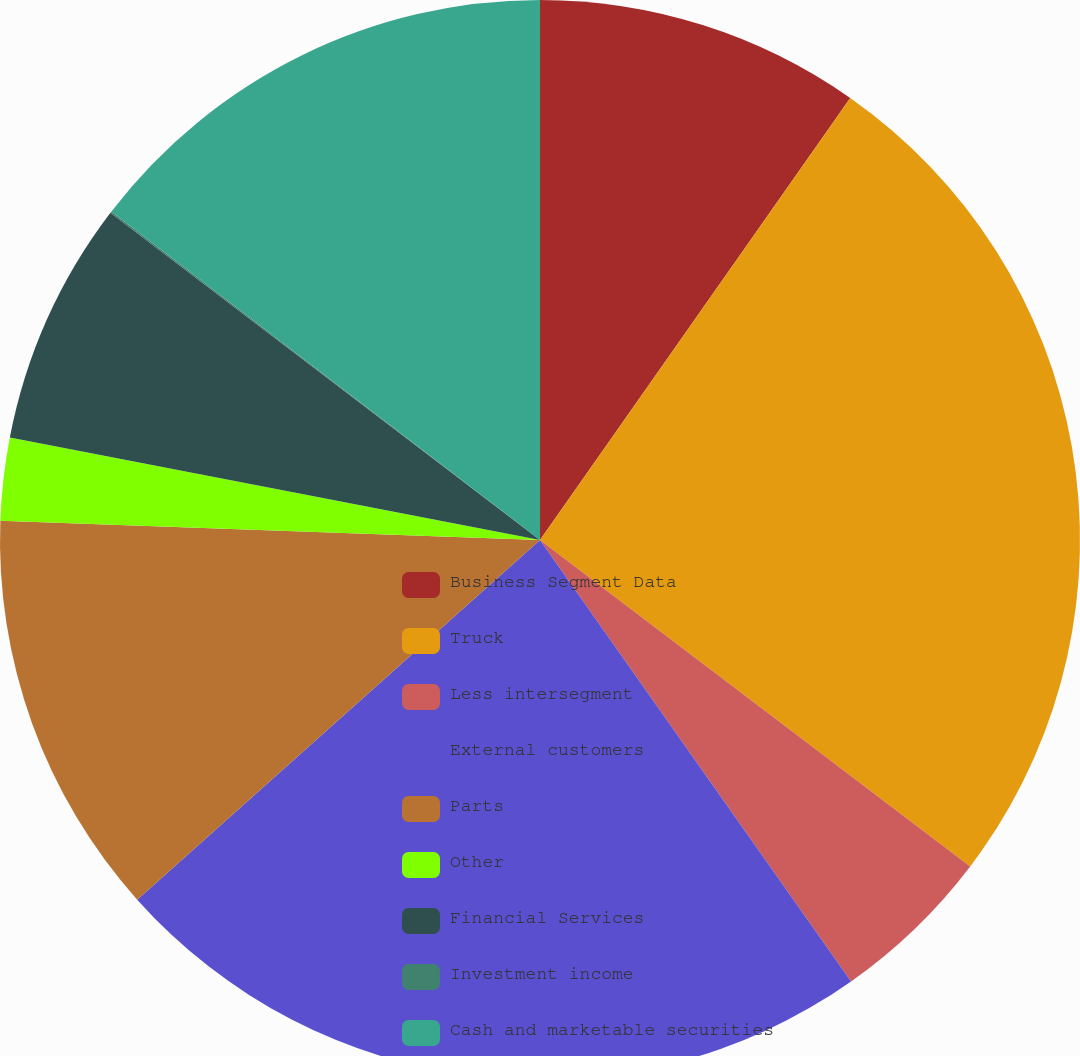Convert chart. <chart><loc_0><loc_0><loc_500><loc_500><pie_chart><fcel>Business Segment Data<fcel>Truck<fcel>Less intersegment<fcel>External customers<fcel>Parts<fcel>Other<fcel>Financial Services<fcel>Investment income<fcel>Cash and marketable securities<nl><fcel>9.74%<fcel>25.59%<fcel>4.9%<fcel>23.17%<fcel>12.17%<fcel>2.47%<fcel>7.32%<fcel>0.05%<fcel>14.59%<nl></chart> 